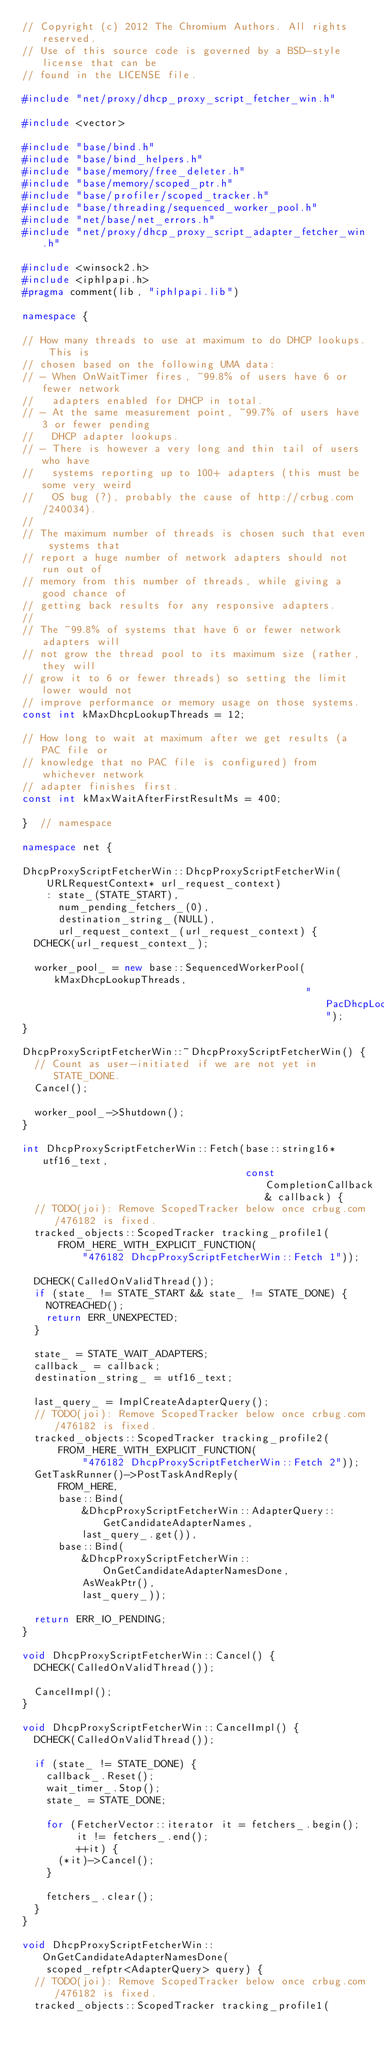<code> <loc_0><loc_0><loc_500><loc_500><_C++_>// Copyright (c) 2012 The Chromium Authors. All rights reserved.
// Use of this source code is governed by a BSD-style license that can be
// found in the LICENSE file.

#include "net/proxy/dhcp_proxy_script_fetcher_win.h"

#include <vector>

#include "base/bind.h"
#include "base/bind_helpers.h"
#include "base/memory/free_deleter.h"
#include "base/memory/scoped_ptr.h"
#include "base/profiler/scoped_tracker.h"
#include "base/threading/sequenced_worker_pool.h"
#include "net/base/net_errors.h"
#include "net/proxy/dhcp_proxy_script_adapter_fetcher_win.h"

#include <winsock2.h>
#include <iphlpapi.h>
#pragma comment(lib, "iphlpapi.lib")

namespace {

// How many threads to use at maximum to do DHCP lookups. This is
// chosen based on the following UMA data:
// - When OnWaitTimer fires, ~99.8% of users have 6 or fewer network
//   adapters enabled for DHCP in total.
// - At the same measurement point, ~99.7% of users have 3 or fewer pending
//   DHCP adapter lookups.
// - There is however a very long and thin tail of users who have
//   systems reporting up to 100+ adapters (this must be some very weird
//   OS bug (?), probably the cause of http://crbug.com/240034).
//
// The maximum number of threads is chosen such that even systems that
// report a huge number of network adapters should not run out of
// memory from this number of threads, while giving a good chance of
// getting back results for any responsive adapters.
//
// The ~99.8% of systems that have 6 or fewer network adapters will
// not grow the thread pool to its maximum size (rather, they will
// grow it to 6 or fewer threads) so setting the limit lower would not
// improve performance or memory usage on those systems.
const int kMaxDhcpLookupThreads = 12;

// How long to wait at maximum after we get results (a PAC file or
// knowledge that no PAC file is configured) from whichever network
// adapter finishes first.
const int kMaxWaitAfterFirstResultMs = 400;

}  // namespace

namespace net {

DhcpProxyScriptFetcherWin::DhcpProxyScriptFetcherWin(
    URLRequestContext* url_request_context)
    : state_(STATE_START),
      num_pending_fetchers_(0),
      destination_string_(NULL),
      url_request_context_(url_request_context) {
  DCHECK(url_request_context_);

  worker_pool_ = new base::SequencedWorkerPool(kMaxDhcpLookupThreads,
                                               "PacDhcpLookup");
}

DhcpProxyScriptFetcherWin::~DhcpProxyScriptFetcherWin() {
  // Count as user-initiated if we are not yet in STATE_DONE.
  Cancel();

  worker_pool_->Shutdown();
}

int DhcpProxyScriptFetcherWin::Fetch(base::string16* utf16_text,
                                     const CompletionCallback& callback) {
  // TODO(joi): Remove ScopedTracker below once crbug.com/476182 is fixed.
  tracked_objects::ScopedTracker tracking_profile1(
      FROM_HERE_WITH_EXPLICIT_FUNCTION(
          "476182 DhcpProxyScriptFetcherWin::Fetch 1"));

  DCHECK(CalledOnValidThread());
  if (state_ != STATE_START && state_ != STATE_DONE) {
    NOTREACHED();
    return ERR_UNEXPECTED;
  }

  state_ = STATE_WAIT_ADAPTERS;
  callback_ = callback;
  destination_string_ = utf16_text;

  last_query_ = ImplCreateAdapterQuery();
  // TODO(joi): Remove ScopedTracker below once crbug.com/476182 is fixed.
  tracked_objects::ScopedTracker tracking_profile2(
      FROM_HERE_WITH_EXPLICIT_FUNCTION(
          "476182 DhcpProxyScriptFetcherWin::Fetch 2"));
  GetTaskRunner()->PostTaskAndReply(
      FROM_HERE,
      base::Bind(
          &DhcpProxyScriptFetcherWin::AdapterQuery::GetCandidateAdapterNames,
          last_query_.get()),
      base::Bind(
          &DhcpProxyScriptFetcherWin::OnGetCandidateAdapterNamesDone,
          AsWeakPtr(),
          last_query_));

  return ERR_IO_PENDING;
}

void DhcpProxyScriptFetcherWin::Cancel() {
  DCHECK(CalledOnValidThread());

  CancelImpl();
}

void DhcpProxyScriptFetcherWin::CancelImpl() {
  DCHECK(CalledOnValidThread());

  if (state_ != STATE_DONE) {
    callback_.Reset();
    wait_timer_.Stop();
    state_ = STATE_DONE;

    for (FetcherVector::iterator it = fetchers_.begin();
         it != fetchers_.end();
         ++it) {
      (*it)->Cancel();
    }

    fetchers_.clear();
  }
}

void DhcpProxyScriptFetcherWin::OnGetCandidateAdapterNamesDone(
    scoped_refptr<AdapterQuery> query) {
  // TODO(joi): Remove ScopedTracker below once crbug.com/476182 is fixed.
  tracked_objects::ScopedTracker tracking_profile1(</code> 